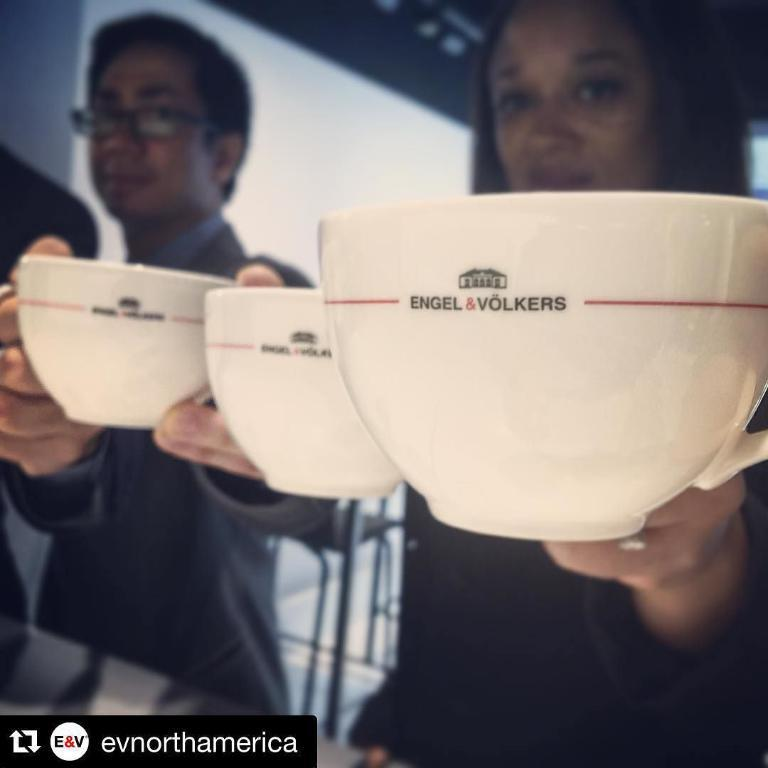What objects are present in the image that are typically used for drinking? There are tea cups in the image. What is written or printed on the tea cups? The tea cups have text on them. Can you describe the people in the image? There are people in the image, but their specific actions or appearances are not mentioned in the provided facts. What type of rake is being used by the people in the image? There is no rake present in the image. What is the purpose of the protest depicted in the image? There is no protest depicted in the image. 